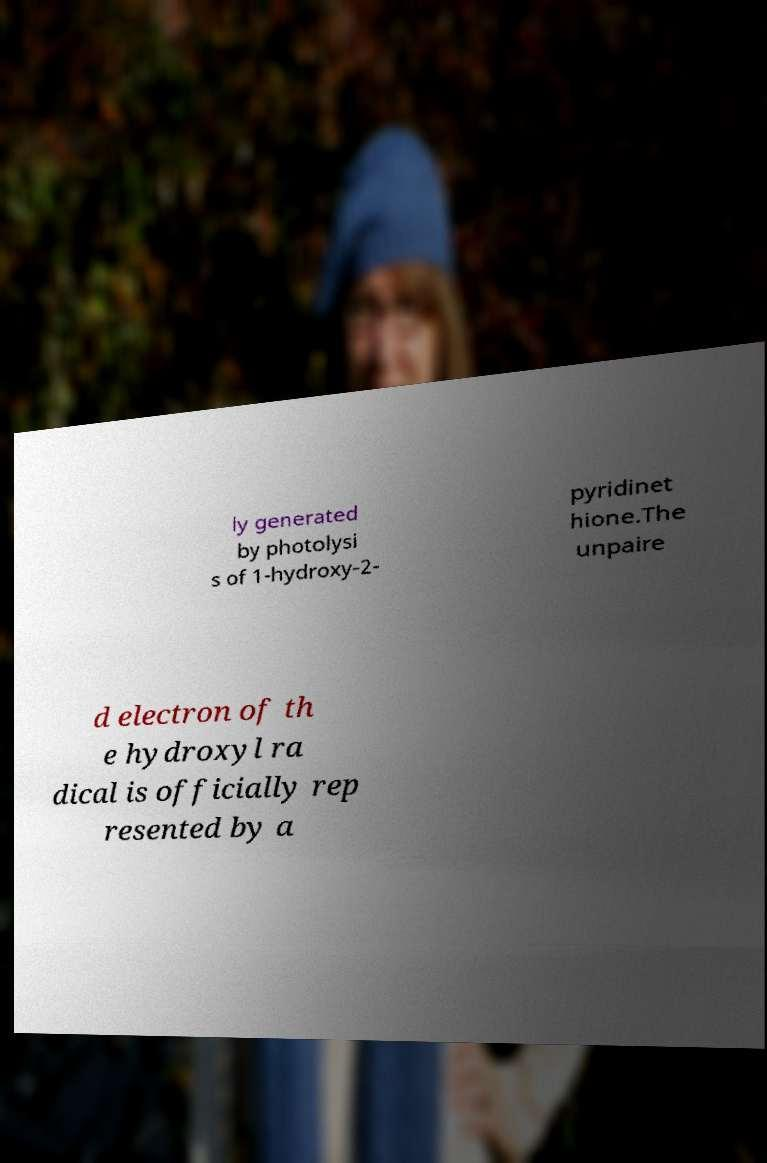I need the written content from this picture converted into text. Can you do that? ly generated by photolysi s of 1-hydroxy-2- pyridinet hione.The unpaire d electron of th e hydroxyl ra dical is officially rep resented by a 